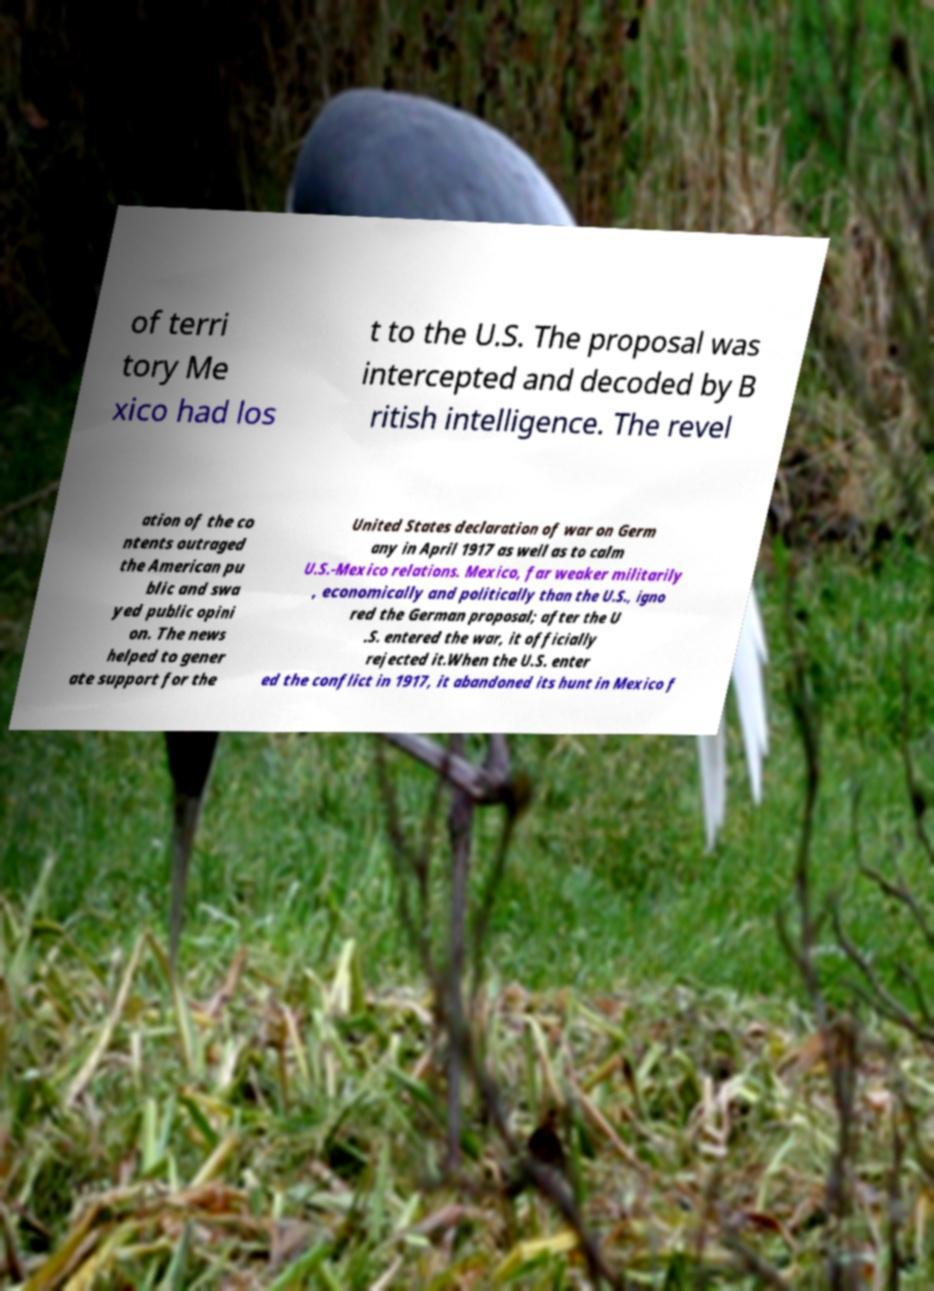Could you assist in decoding the text presented in this image and type it out clearly? of terri tory Me xico had los t to the U.S. The proposal was intercepted and decoded by B ritish intelligence. The revel ation of the co ntents outraged the American pu blic and swa yed public opini on. The news helped to gener ate support for the United States declaration of war on Germ any in April 1917 as well as to calm U.S.-Mexico relations. Mexico, far weaker militarily , economically and politically than the U.S., igno red the German proposal; after the U .S. entered the war, it officially rejected it.When the U.S. enter ed the conflict in 1917, it abandoned its hunt in Mexico f 